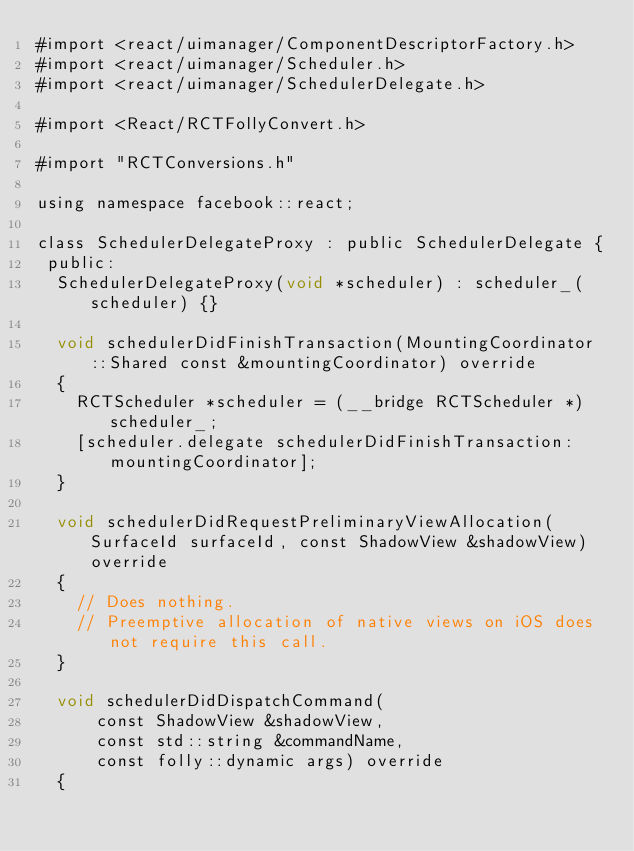<code> <loc_0><loc_0><loc_500><loc_500><_ObjectiveC_>#import <react/uimanager/ComponentDescriptorFactory.h>
#import <react/uimanager/Scheduler.h>
#import <react/uimanager/SchedulerDelegate.h>

#import <React/RCTFollyConvert.h>

#import "RCTConversions.h"

using namespace facebook::react;

class SchedulerDelegateProxy : public SchedulerDelegate {
 public:
  SchedulerDelegateProxy(void *scheduler) : scheduler_(scheduler) {}

  void schedulerDidFinishTransaction(MountingCoordinator::Shared const &mountingCoordinator) override
  {
    RCTScheduler *scheduler = (__bridge RCTScheduler *)scheduler_;
    [scheduler.delegate schedulerDidFinishTransaction:mountingCoordinator];
  }

  void schedulerDidRequestPreliminaryViewAllocation(SurfaceId surfaceId, const ShadowView &shadowView) override
  {
    // Does nothing.
    // Preemptive allocation of native views on iOS does not require this call.
  }

  void schedulerDidDispatchCommand(
      const ShadowView &shadowView,
      const std::string &commandName,
      const folly::dynamic args) override
  {</code> 